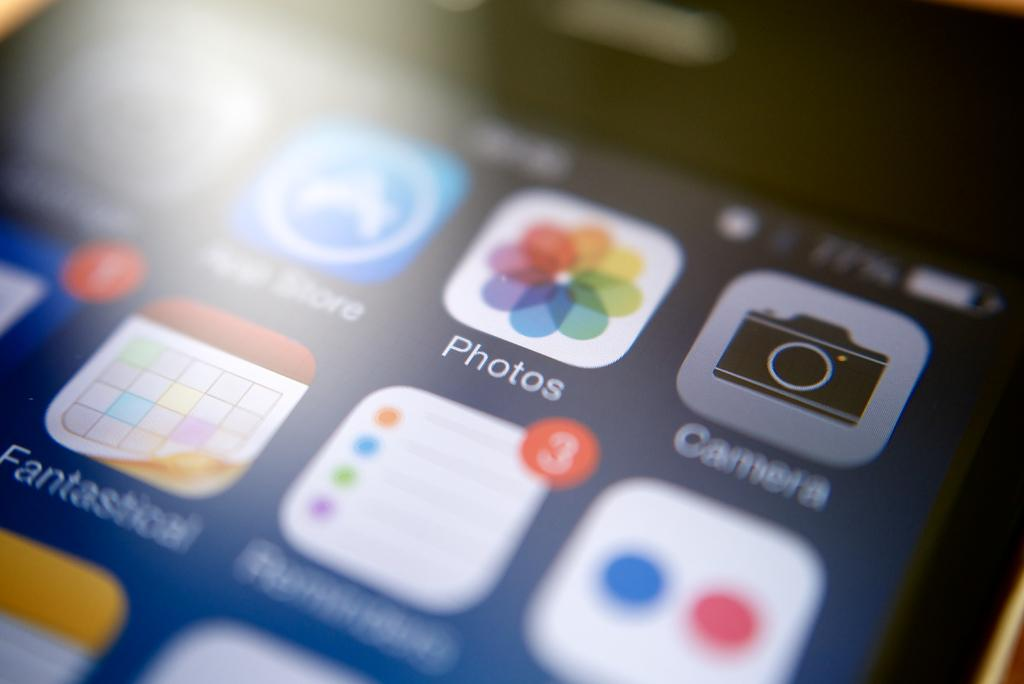<image>
Describe the image concisely. A cell phone screen with a photos icon. 